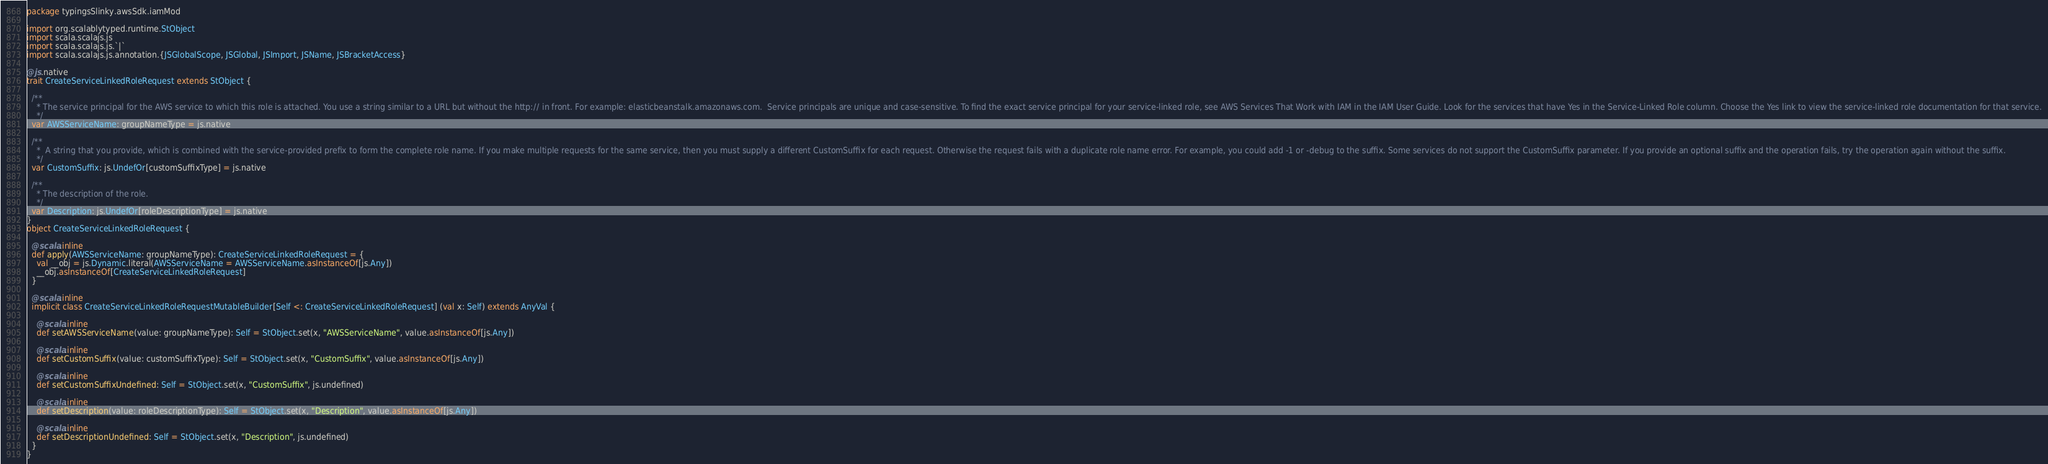<code> <loc_0><loc_0><loc_500><loc_500><_Scala_>package typingsSlinky.awsSdk.iamMod

import org.scalablytyped.runtime.StObject
import scala.scalajs.js
import scala.scalajs.js.`|`
import scala.scalajs.js.annotation.{JSGlobalScope, JSGlobal, JSImport, JSName, JSBracketAccess}

@js.native
trait CreateServiceLinkedRoleRequest extends StObject {
  
  /**
    * The service principal for the AWS service to which this role is attached. You use a string similar to a URL but without the http:// in front. For example: elasticbeanstalk.amazonaws.com.  Service principals are unique and case-sensitive. To find the exact service principal for your service-linked role, see AWS Services That Work with IAM in the IAM User Guide. Look for the services that have Yes in the Service-Linked Role column. Choose the Yes link to view the service-linked role documentation for that service.
    */
  var AWSServiceName: groupNameType = js.native
  
  /**
    *  A string that you provide, which is combined with the service-provided prefix to form the complete role name. If you make multiple requests for the same service, then you must supply a different CustomSuffix for each request. Otherwise the request fails with a duplicate role name error. For example, you could add -1 or -debug to the suffix. Some services do not support the CustomSuffix parameter. If you provide an optional suffix and the operation fails, try the operation again without the suffix.
    */
  var CustomSuffix: js.UndefOr[customSuffixType] = js.native
  
  /**
    * The description of the role.
    */
  var Description: js.UndefOr[roleDescriptionType] = js.native
}
object CreateServiceLinkedRoleRequest {
  
  @scala.inline
  def apply(AWSServiceName: groupNameType): CreateServiceLinkedRoleRequest = {
    val __obj = js.Dynamic.literal(AWSServiceName = AWSServiceName.asInstanceOf[js.Any])
    __obj.asInstanceOf[CreateServiceLinkedRoleRequest]
  }
  
  @scala.inline
  implicit class CreateServiceLinkedRoleRequestMutableBuilder[Self <: CreateServiceLinkedRoleRequest] (val x: Self) extends AnyVal {
    
    @scala.inline
    def setAWSServiceName(value: groupNameType): Self = StObject.set(x, "AWSServiceName", value.asInstanceOf[js.Any])
    
    @scala.inline
    def setCustomSuffix(value: customSuffixType): Self = StObject.set(x, "CustomSuffix", value.asInstanceOf[js.Any])
    
    @scala.inline
    def setCustomSuffixUndefined: Self = StObject.set(x, "CustomSuffix", js.undefined)
    
    @scala.inline
    def setDescription(value: roleDescriptionType): Self = StObject.set(x, "Description", value.asInstanceOf[js.Any])
    
    @scala.inline
    def setDescriptionUndefined: Self = StObject.set(x, "Description", js.undefined)
  }
}
</code> 